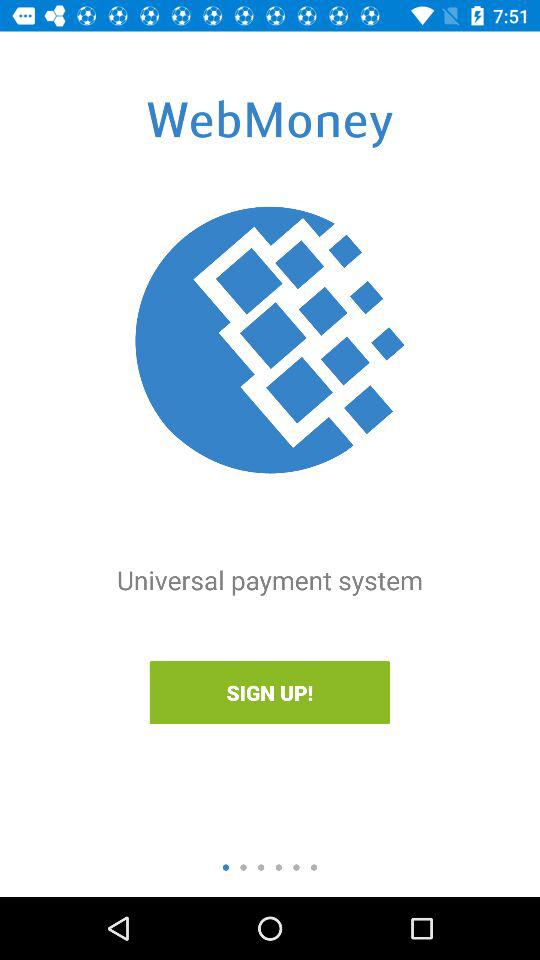What is the application name? The application name is "WebMoney". 